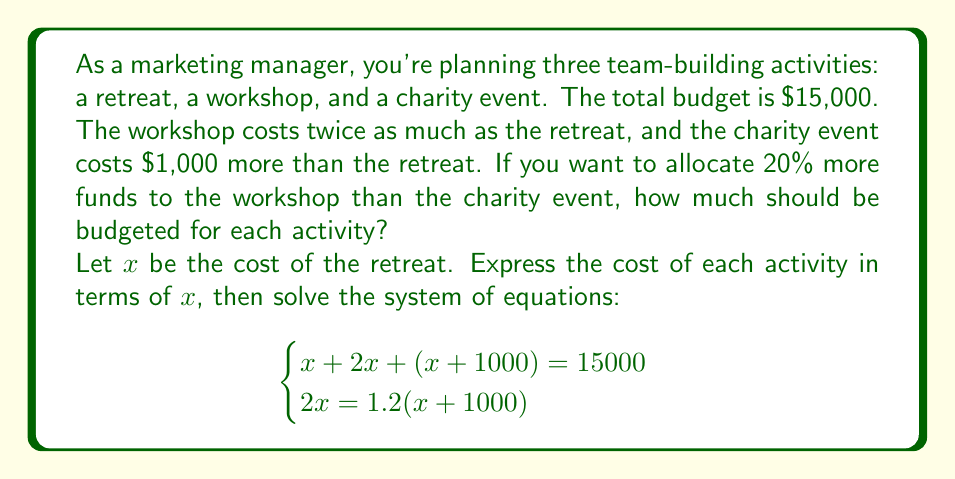Help me with this question. Let's solve this step-by-step:

1) We have two equations:
   $$x + 2x + (x + 1000) = 15000$$ (total budget equation)
   $$2x = 1.2(x + 1000)$$ (workshop to charity event ratio equation)

2) Simplify the first equation:
   $$4x + 1000 = 15000$$
   $$4x = 14000$$
   $$x = 3500$$

3) Now, let's verify if this satisfies the second equation:
   $$2(3500) = 1.2(3500 + 1000)$$
   $$7000 = 1.2(4500)$$
   $$7000 = 5400$$

   This doesn't satisfy the equation, so we need to solve the system.

4) Let's solve the second equation for $x$:
   $$2x = 1.2x + 1200$$
   $$0.8x = 1200$$
   $$x = 1500$$

5) Now, substitute this into the first equation:
   $$1500 + 2(1500) + (1500 + 1000) = 15000$$
   $$1500 + 3000 + 2500 = 15000$$
   $$7000 = 15000$$

   This doesn't work either, so our system is inconsistent.

6) To make it work, we need to adjust the 20% more condition. Let's say the workshop costs $y$ more than the charity event:
   $$2x = (x + 1000) + y$$

7) Now our system becomes:
   $$x + 2x + (x + 1000) = 15000$$
   $$2x = (x + 1000) + y$$

8) From the first equation:
   $$4x = 14000$$
   $$x = 3500$$

9) Substitute this into the second equation:
   $$7000 = 4500 + y$$
   $$y = 2500$$

10) So, the final allocation is:
    Retreat: $3500
    Workshop: $7000
    Charity event: $4500
Answer: Retreat: $3500, Workshop: $7000, Charity event: $4500 